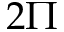<formula> <loc_0><loc_0><loc_500><loc_500>2 \Pi</formula> 